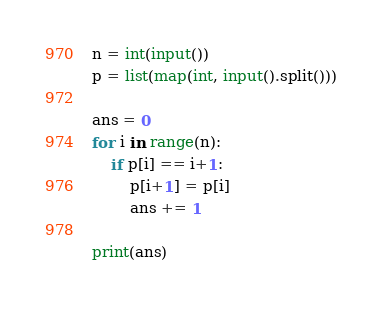Convert code to text. <code><loc_0><loc_0><loc_500><loc_500><_Python_>n = int(input())
p = list(map(int, input().split()))

ans = 0
for i in range(n):
    if p[i] == i+1:
        p[i+1] = p[i]
        ans += 1

print(ans)</code> 